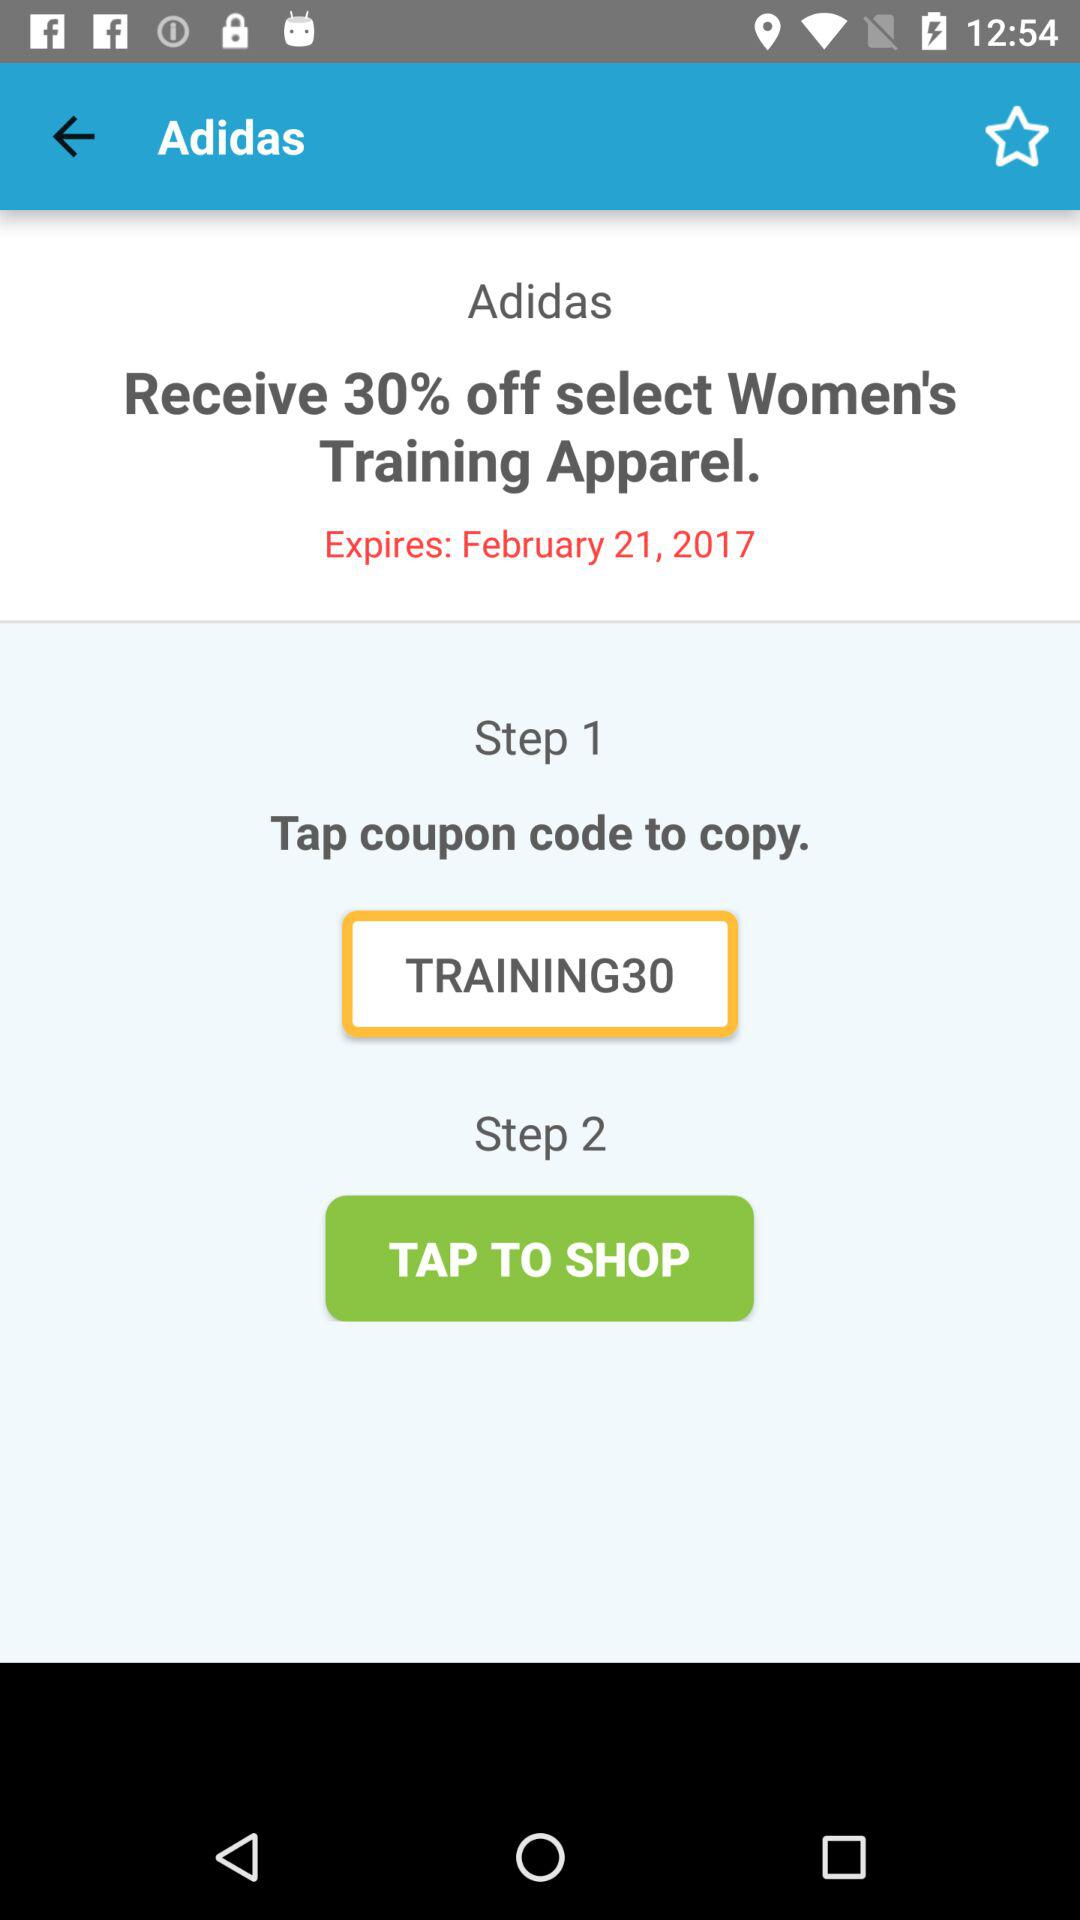What is the coupon code? The coupon code is "TRAINING30". 